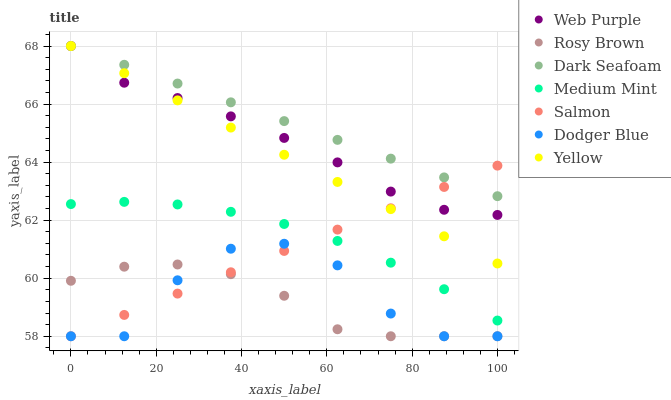Does Rosy Brown have the minimum area under the curve?
Answer yes or no. Yes. Does Dark Seafoam have the maximum area under the curve?
Answer yes or no. Yes. Does Salmon have the minimum area under the curve?
Answer yes or no. No. Does Salmon have the maximum area under the curve?
Answer yes or no. No. Is Salmon the smoothest?
Answer yes or no. Yes. Is Dodger Blue the roughest?
Answer yes or no. Yes. Is Rosy Brown the smoothest?
Answer yes or no. No. Is Rosy Brown the roughest?
Answer yes or no. No. Does Rosy Brown have the lowest value?
Answer yes or no. Yes. Does Dark Seafoam have the lowest value?
Answer yes or no. No. Does Web Purple have the highest value?
Answer yes or no. Yes. Does Salmon have the highest value?
Answer yes or no. No. Is Dodger Blue less than Medium Mint?
Answer yes or no. Yes. Is Web Purple greater than Medium Mint?
Answer yes or no. Yes. Does Salmon intersect Web Purple?
Answer yes or no. Yes. Is Salmon less than Web Purple?
Answer yes or no. No. Is Salmon greater than Web Purple?
Answer yes or no. No. Does Dodger Blue intersect Medium Mint?
Answer yes or no. No. 